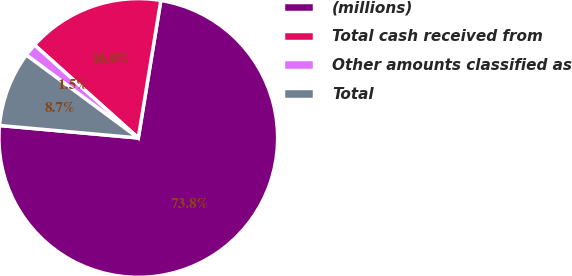Convert chart. <chart><loc_0><loc_0><loc_500><loc_500><pie_chart><fcel>(millions)<fcel>Total cash received from<fcel>Other amounts classified as<fcel>Total<nl><fcel>73.84%<fcel>15.96%<fcel>1.48%<fcel>8.72%<nl></chart> 